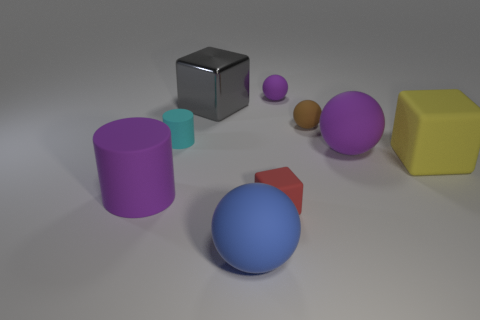Add 1 large purple objects. How many objects exist? 10 Subtract all blocks. How many objects are left? 6 Subtract all yellow matte things. Subtract all red matte objects. How many objects are left? 7 Add 6 small purple things. How many small purple things are left? 7 Add 8 large purple rubber objects. How many large purple rubber objects exist? 10 Subtract 0 purple blocks. How many objects are left? 9 